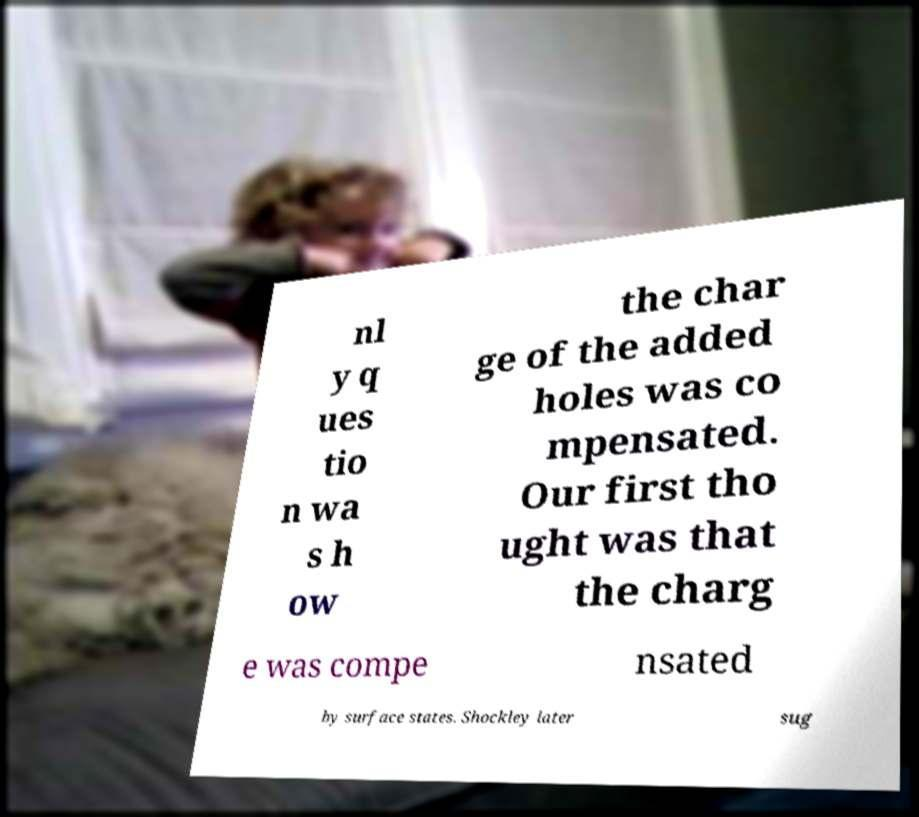Can you accurately transcribe the text from the provided image for me? nl y q ues tio n wa s h ow the char ge of the added holes was co mpensated. Our first tho ught was that the charg e was compe nsated by surface states. Shockley later sug 